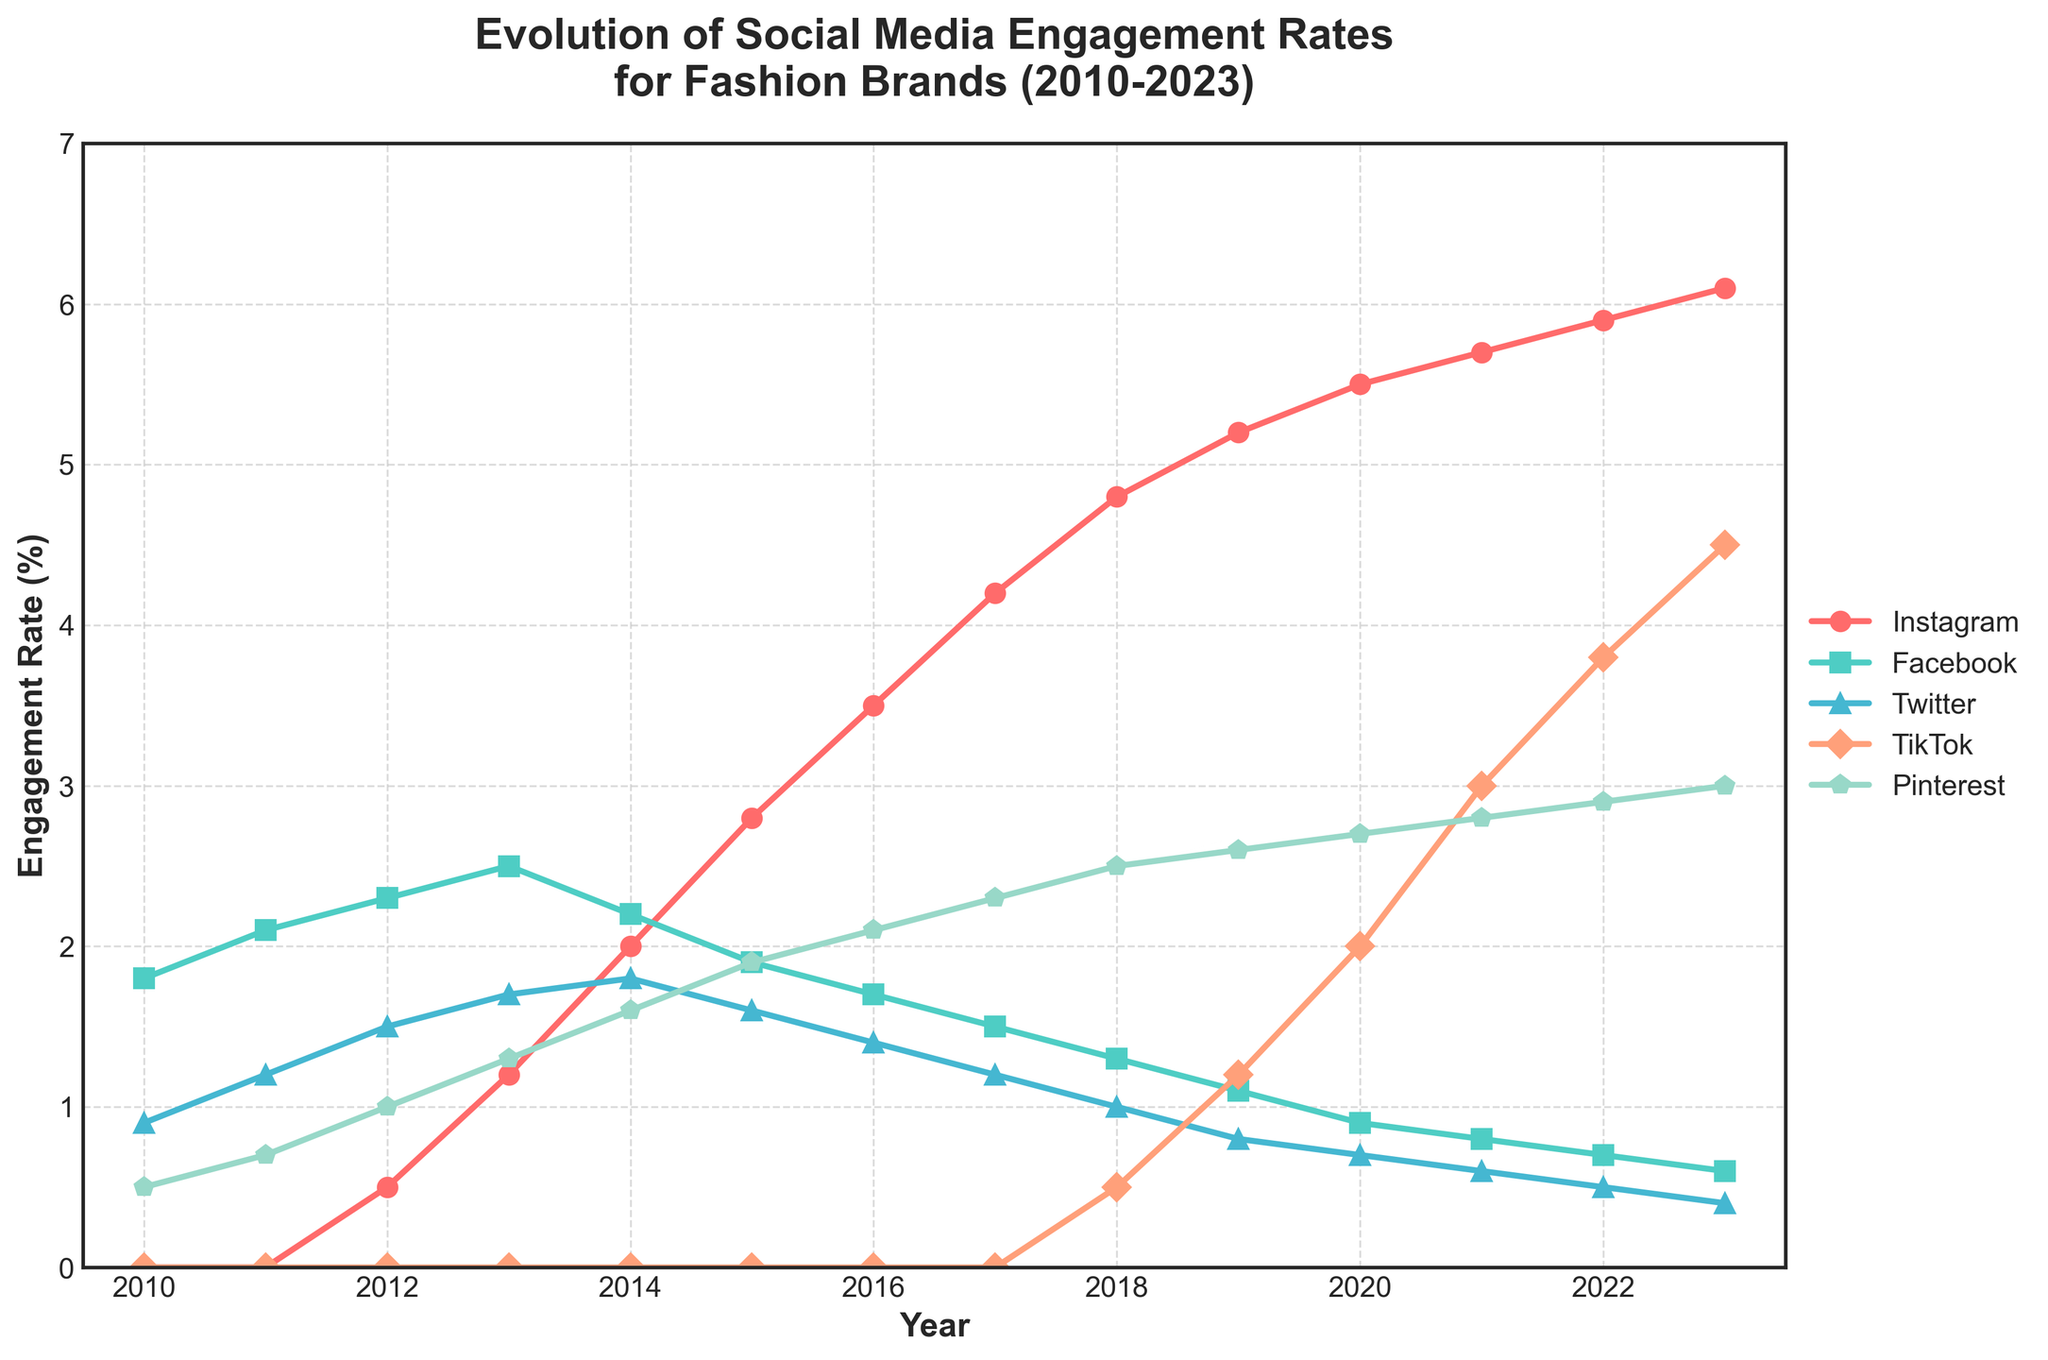what platform saw the highest engagement rate in 2023? Look at the rightmost end of the chart, locate which platform's line is at the highest position.
Answer: Instagram how did TikTok's engagement rate compare to Pinterest's in 2021? Refer to the 2021 point on the chart, compare the height of TikTok’s and Pinterest's lines.
Answer: Higher which platform experienced a decline in engagement from 2013 to 2014? Look at the lines between 2013 and 2014 and see which platform’s engagement rate decreased.
Answer: Facebook what was the difference in engagement rate between Instagram and Facebook in 2018? Find the 2018 points on Instagram's and Facebook's lines, subtract Facebook’s engagement rate from Instagram’s.
Answer: 4.8 - 1.3 = 3.5 which year did Instagram begin to surpass Facebook in engagement rate? Observe the trend of the lines for Instagram and Facebook, identify the year when Instagram's line crosses above Facebook’s.
Answer: 2014 what is the average engagement rate for Pinterest between 2011 and 2015? Identify the engagement rates for Pinterest from 2011, 2012, 2013, 2014, and 2015, sum these values and divide by 5.
Answer: (0.7 + 1.0 + 1.3 + 1.6 + 1.9) / 5 = 1.3 which platform had the lowest engagement rate in 2020? Locate the 2020 point on the chart and identify the lowest line.
Answer: Twitter how has Facebook's engagement rate changed from 2010 to 2023? Observe the trend of the Facebook line from the leftmost to the rightmost point, noting the decrease.
Answer: Decreased which platform was introduced last and in which year? Locate the line that starts the latest, identify the year on the x-axis.
Answer: TikTok, 2018 what is the difference in engagement rate between the highest platform in 2010 and the highest platform in 2023? Identify the highest platform in 2010 (Facebook) and 2023 (Instagram), subtract the 2010 value from the 2023 value.
Answer: 6.1 - 2.1 = 4 